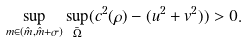Convert formula to latex. <formula><loc_0><loc_0><loc_500><loc_500>\sup _ { m \in ( \hat { m } , \hat { m } + \sigma ) } \sup _ { \bar { \Omega } } ( c ^ { 2 } ( \rho ) - ( u ^ { 2 } + v ^ { 2 } ) ) > 0 .</formula> 